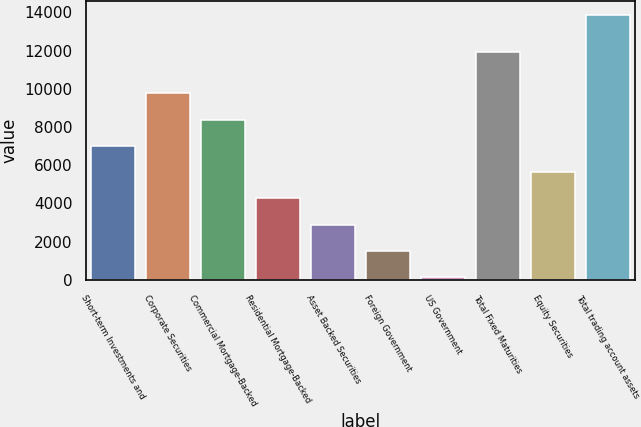Convert chart to OTSL. <chart><loc_0><loc_0><loc_500><loc_500><bar_chart><fcel>Short-term Investments and<fcel>Corporate Securities<fcel>Commercial Mortgage-Backed<fcel>Residential Mortgage-Backed<fcel>Asset Backed Securities<fcel>Foreign Government<fcel>US Government<fcel>Total Fixed Maturities<fcel>Equity Securities<fcel>Total trading account assets<nl><fcel>7009<fcel>9755.4<fcel>8382.2<fcel>4262.6<fcel>2889.4<fcel>1516.2<fcel>143<fcel>11945<fcel>5635.8<fcel>13875<nl></chart> 